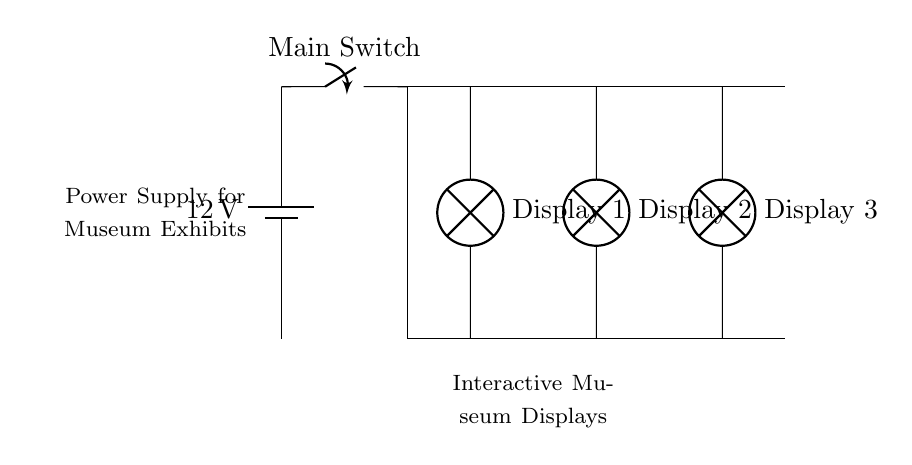What is the voltage of this circuit? The voltage is 12 volts, which is the potential difference provided by the battery at the circuit's origin.
Answer: 12 volts What components are connected in parallel? The circuit has three displays, labeled as Display 1, Display 2, and Display 3, which are all connected parallelly to the main circuit without interruption.
Answer: Display 1, Display 2, Display 3 How many interactive museum displays does this circuit support? The circuit supports three displays, as indicated by the three separate branches from the main line extending to the displays.
Answer: Three What is the role of the main switch in this circuit? The main switch controls the flow of current to the parallel circuit, acting as a gate to turn the entire setup on or off.
Answer: Controls current flow If one display fails, what happens to the others? The other displays remain functional because they are in parallel; each branch operates independently.
Answer: Remain functional 